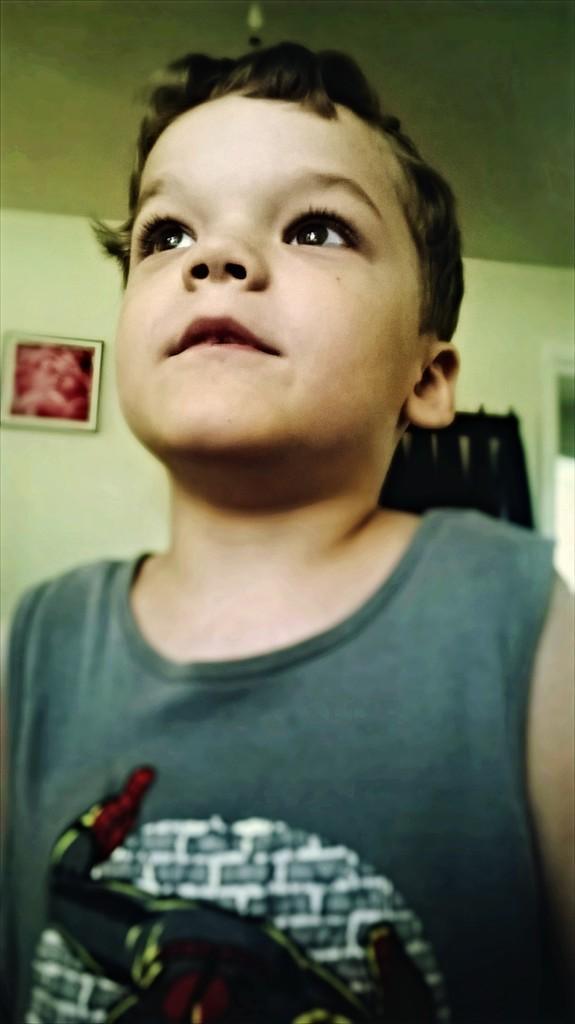Please provide a concise description of this image. In the center of the image there is a boy. In the background there is a frame attached to the plain wall. At the top there is ceiling. 